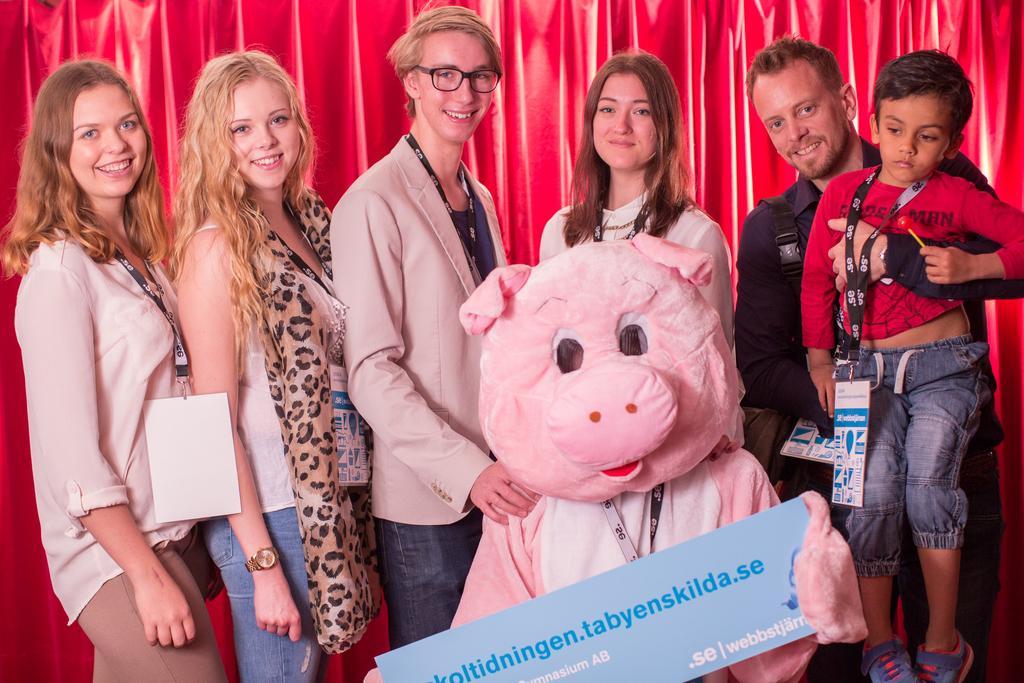Please provide a concise description of this image. In the middle a man is standing, he wore coat and he is holding the teddy pig. Beside him 3 girls are standing, on the right side a man is holding the child in his hand. That child wore an ID card. 